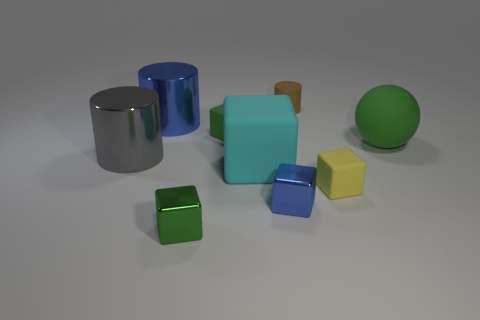There is another green thing that is the same shape as the green metallic thing; what is it made of?
Your response must be concise. Rubber. What number of metallic objects are big spheres or tiny cyan cylinders?
Provide a succinct answer. 0. What is the shape of the tiny yellow thing?
Ensure brevity in your answer.  Cube. Are there any other things that have the same material as the tiny cylinder?
Ensure brevity in your answer.  Yes. Is the cyan cube made of the same material as the blue cylinder?
Give a very brief answer. No. Is there a big rubber sphere to the left of the large metallic cylinder behind the green block behind the gray shiny object?
Offer a terse response. No. How many other things are the same shape as the small green shiny object?
Your answer should be compact. 4. What is the shape of the big object that is behind the large gray metallic cylinder and to the left of the small yellow block?
Ensure brevity in your answer.  Cylinder. There is a tiny metallic thing that is right of the green rubber object that is on the left side of the big rubber thing that is to the right of the brown rubber cylinder; what color is it?
Provide a short and direct response. Blue. Are there more tiny cubes that are behind the small blue block than green balls on the right side of the tiny brown cylinder?
Your answer should be very brief. Yes. 